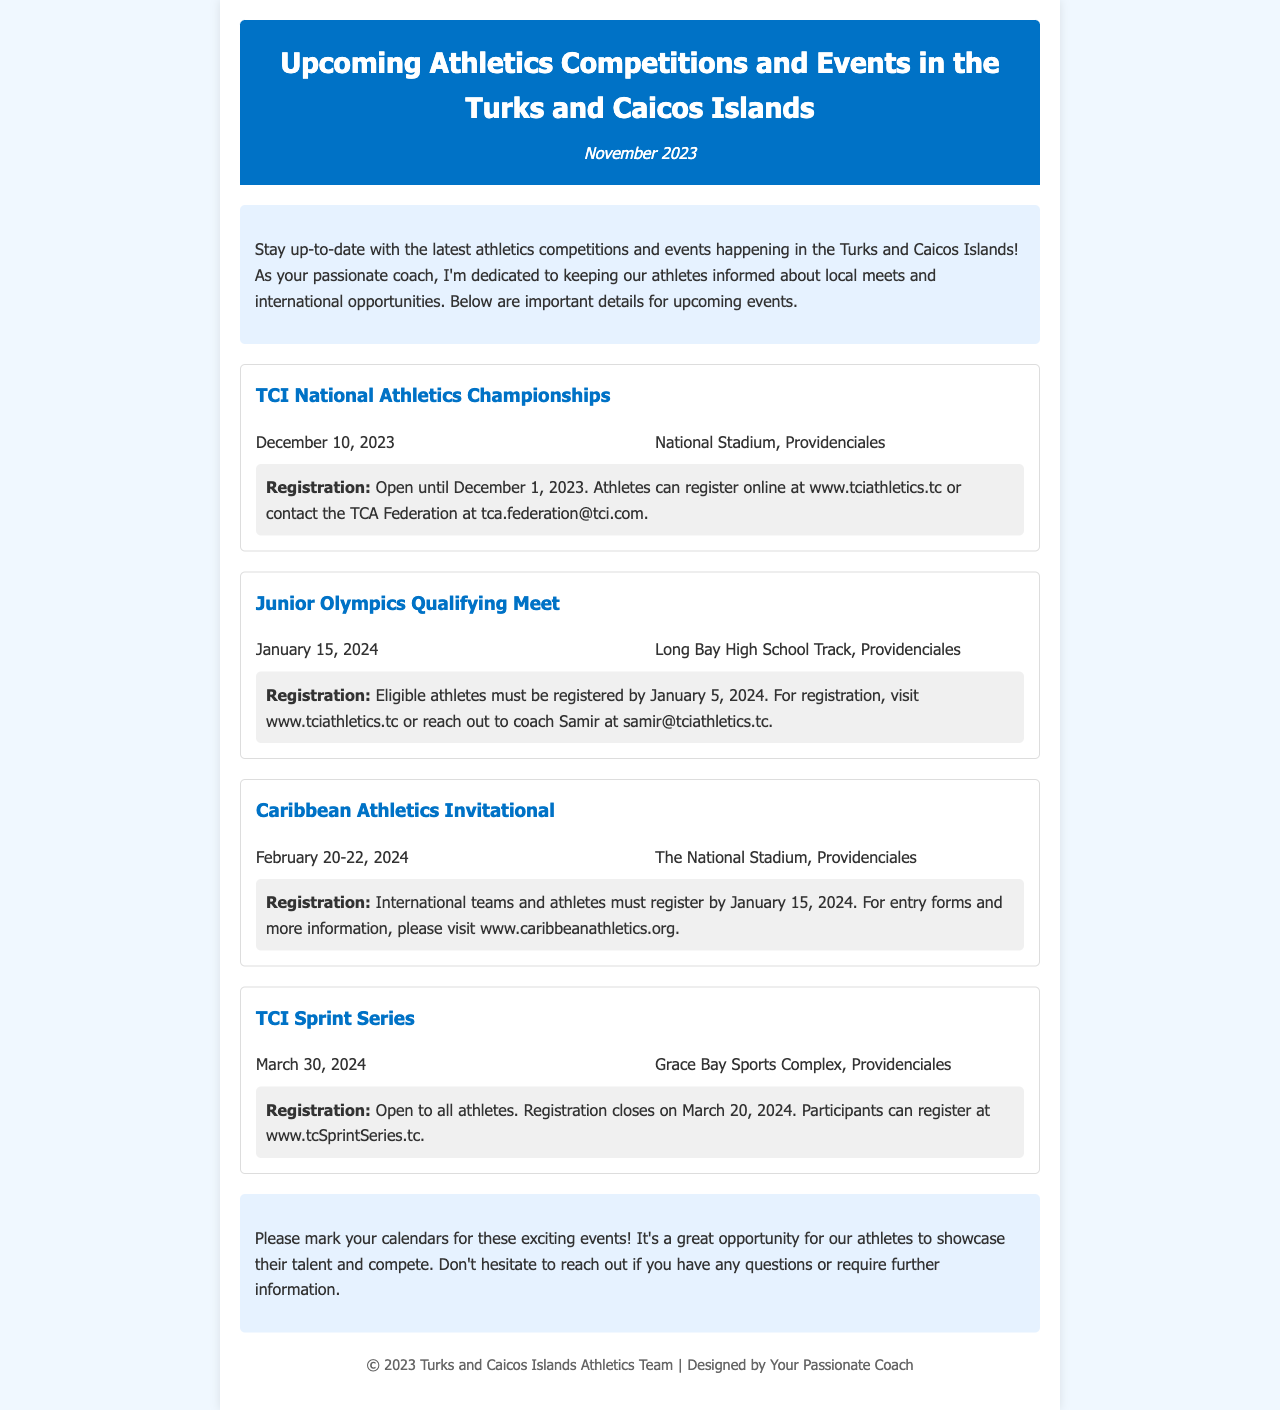What is the date of the TCI National Athletics Championships? The date mentioned for the TCI National Athletics Championships is December 10, 2023.
Answer: December 10, 2023 Where is the Junior Olympics Qualifying Meet being held? The location provided for the Junior Olympics Qualifying Meet is Long Bay High School Track, Providenciales.
Answer: Long Bay High School Track, Providenciales When does registration for the Caribbean Athletics Invitational close? Registration for the Caribbean Athletics Invitational must be completed by January 15, 2024.
Answer: January 15, 2024 What is the name of the event on March 30, 2024? The event taking place on March 30, 2024 is called the TCI Sprint Series.
Answer: TCI Sprint Series How many events are listed in the newsletter? The newsletter includes a total of four upcoming events.
Answer: Four What is the registration deadline for the TCI Sprint Series? The registration deadline for the TCI Sprint Series is March 20, 2024.
Answer: March 20, 2024 Which event occurs first in the series? The first event in the series mentioned is the TCI National Athletics Championships.
Answer: TCI National Athletics Championships What is the primary purpose of this newsletter? The primary purpose of the newsletter is to inform athletes about upcoming competitions and events in the Turks and Caicos Islands.
Answer: To inform athletes about upcoming competitions and events 